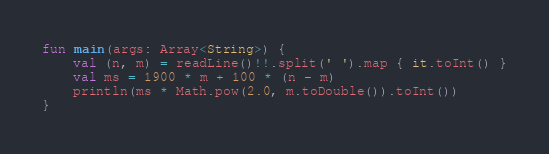<code> <loc_0><loc_0><loc_500><loc_500><_Kotlin_>fun main(args: Array<String>) {
    val (n, m) = readLine()!!.split(' ').map { it.toInt() }
    val ms = 1900 * m + 100 * (n - m)
    println(ms * Math.pow(2.0, m.toDouble()).toInt())
}
</code> 